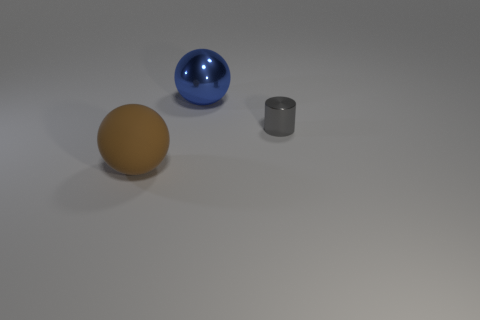How many shiny objects are either small red cylinders or large blue things?
Give a very brief answer. 1. There is a thing right of the large ball that is behind the metallic thing on the right side of the shiny sphere; what is it made of?
Provide a succinct answer. Metal. Does the large thing that is in front of the blue ball have the same shape as the small gray thing on the right side of the large brown rubber object?
Your answer should be very brief. No. There is a ball left of the large object that is to the right of the brown thing; what color is it?
Keep it short and to the point. Brown. What number of balls are small gray objects or blue metal things?
Offer a very short reply. 1. There is a object that is behind the gray metallic cylinder that is right of the large blue shiny object; what number of objects are to the left of it?
Offer a very short reply. 1. Is there a small gray cylinder that has the same material as the blue sphere?
Make the answer very short. Yes. Are the blue thing and the big brown thing made of the same material?
Give a very brief answer. No. There is a shiny thing that is in front of the blue metal sphere; how many large shiny spheres are left of it?
Offer a very short reply. 1. How many red things are either tiny metal objects or tiny cubes?
Your answer should be very brief. 0. 